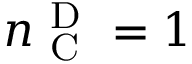Convert formula to latex. <formula><loc_0><loc_0><loc_500><loc_500>n _ { C } ^ { D } = 1</formula> 